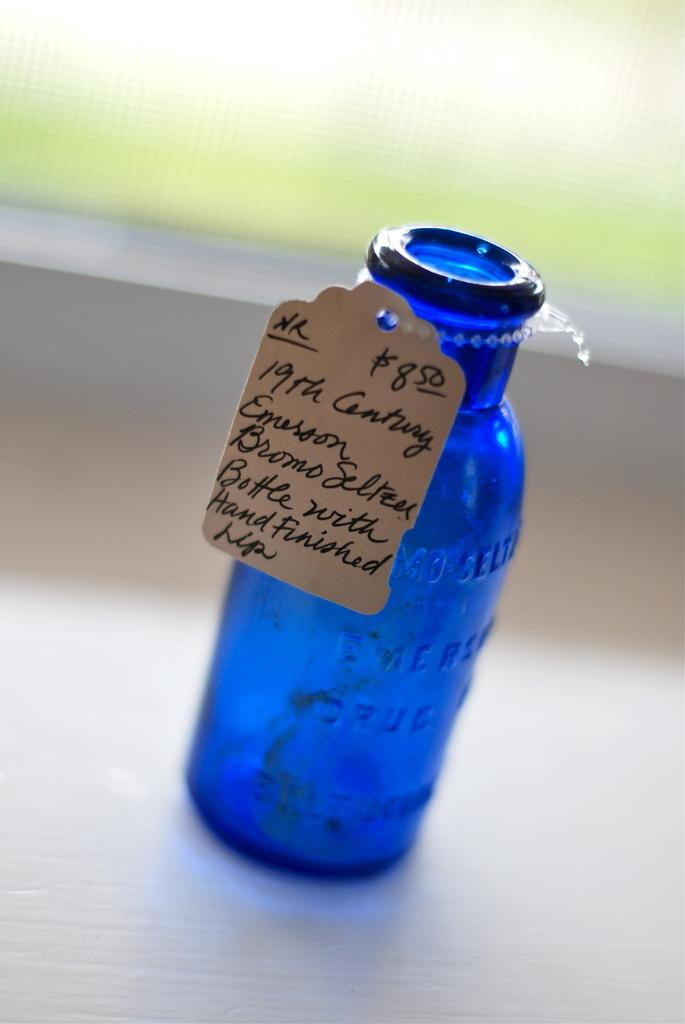<image>
Give a short and clear explanation of the subsequent image. A wee blue glass bottle from the 19th century. 